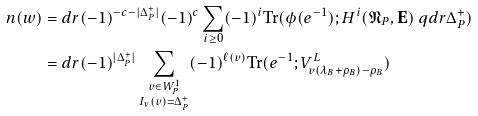<formula> <loc_0><loc_0><loc_500><loc_500>n ( w ) & = d r ( - 1 ) ^ { - c - | \Delta _ { P } ^ { + } | } ( - 1 ) ^ { c } \sum _ { i \geq 0 } ( - 1 ) ^ { i } \text {Tr} ( \phi ( e ^ { - 1 } ) ; H ^ { i } ( \mathfrak N _ { P } , \mathbf E ) \ q d r { \Delta _ { P } ^ { + } } ) \\ & = d r ( - 1 ) ^ { | \Delta _ { P } ^ { + } | } \sum _ { \substack { v \in W ^ { 1 } _ { P } \\ I _ { \nu } ( v ) = \Delta ^ { + } _ { P } } } ( - 1 ) ^ { \ell ( v ) } \text {Tr} ( e ^ { - 1 } ; V ^ { L } _ { v ( \lambda _ { B } + \rho _ { B } ) - \rho _ { B } } )</formula> 